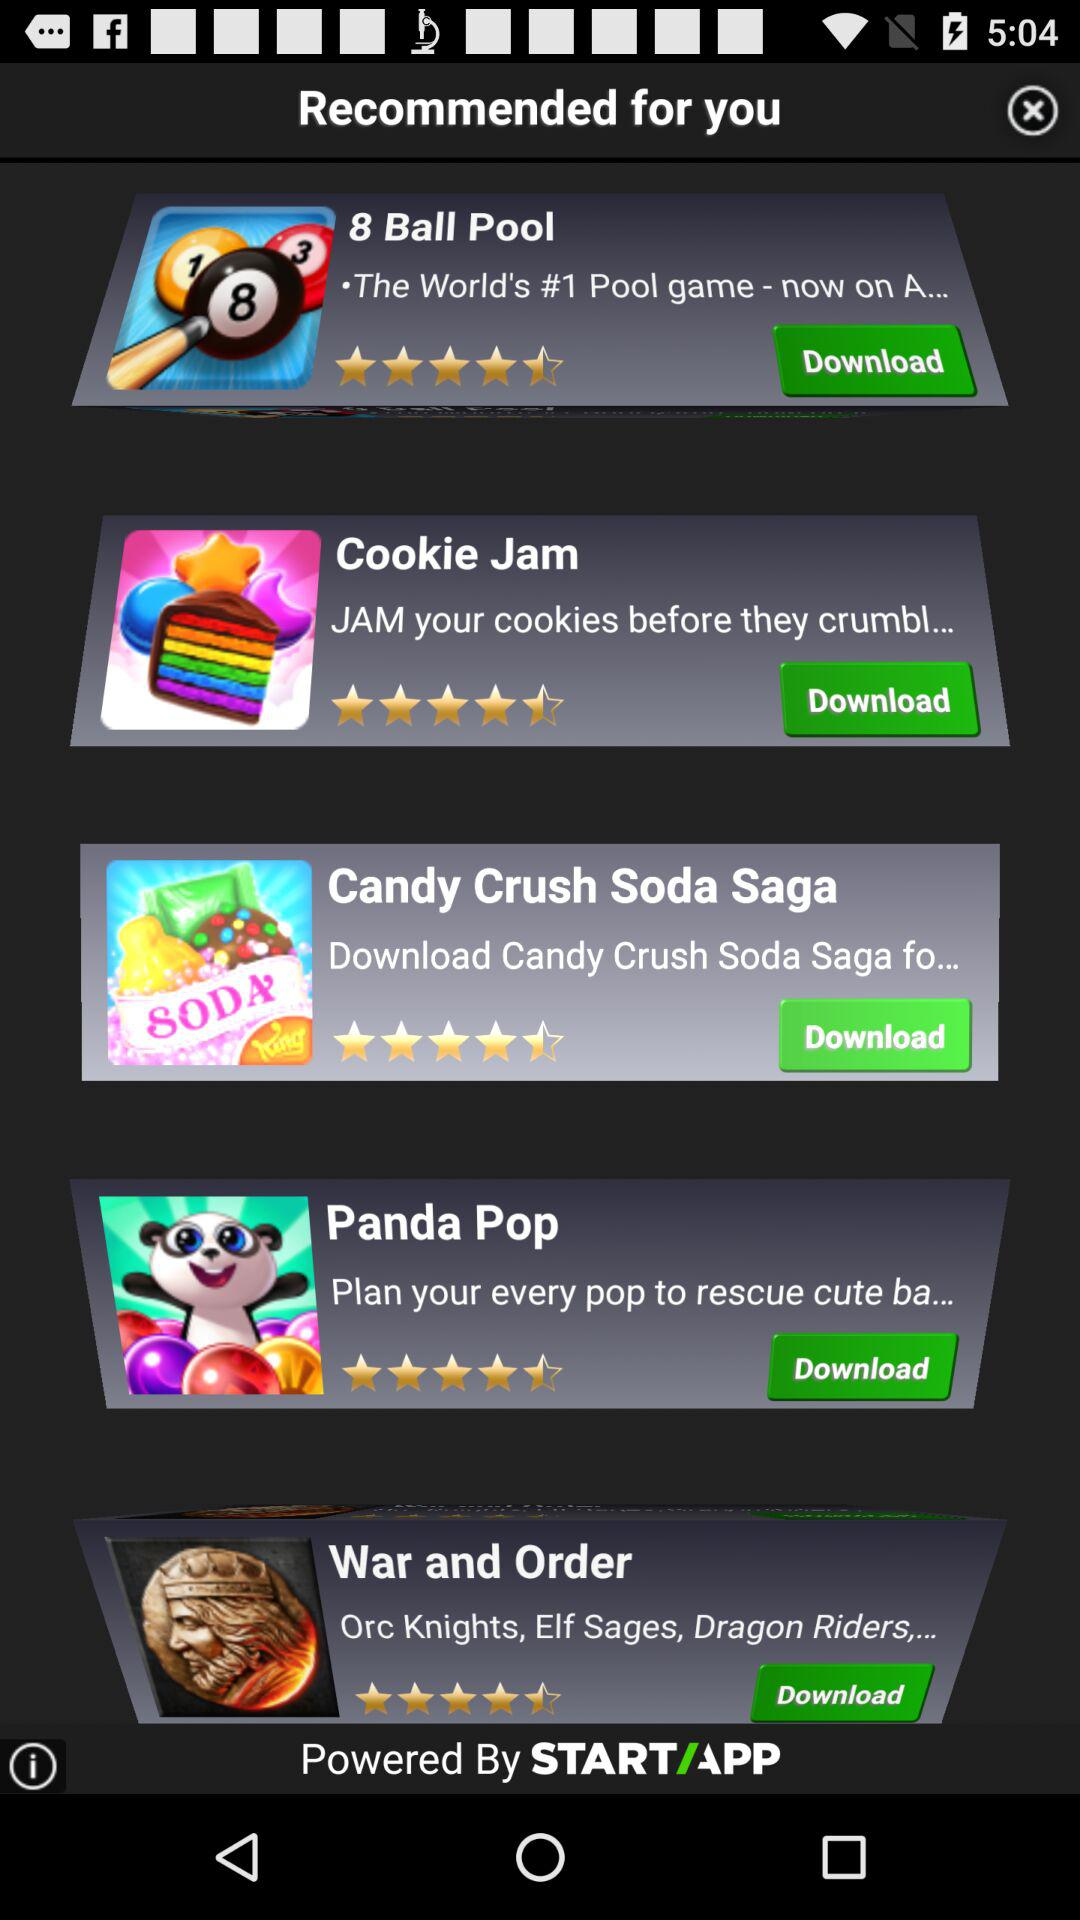How many people reviewed "Panda Pop"?
When the provided information is insufficient, respond with <no answer>. <no answer> 